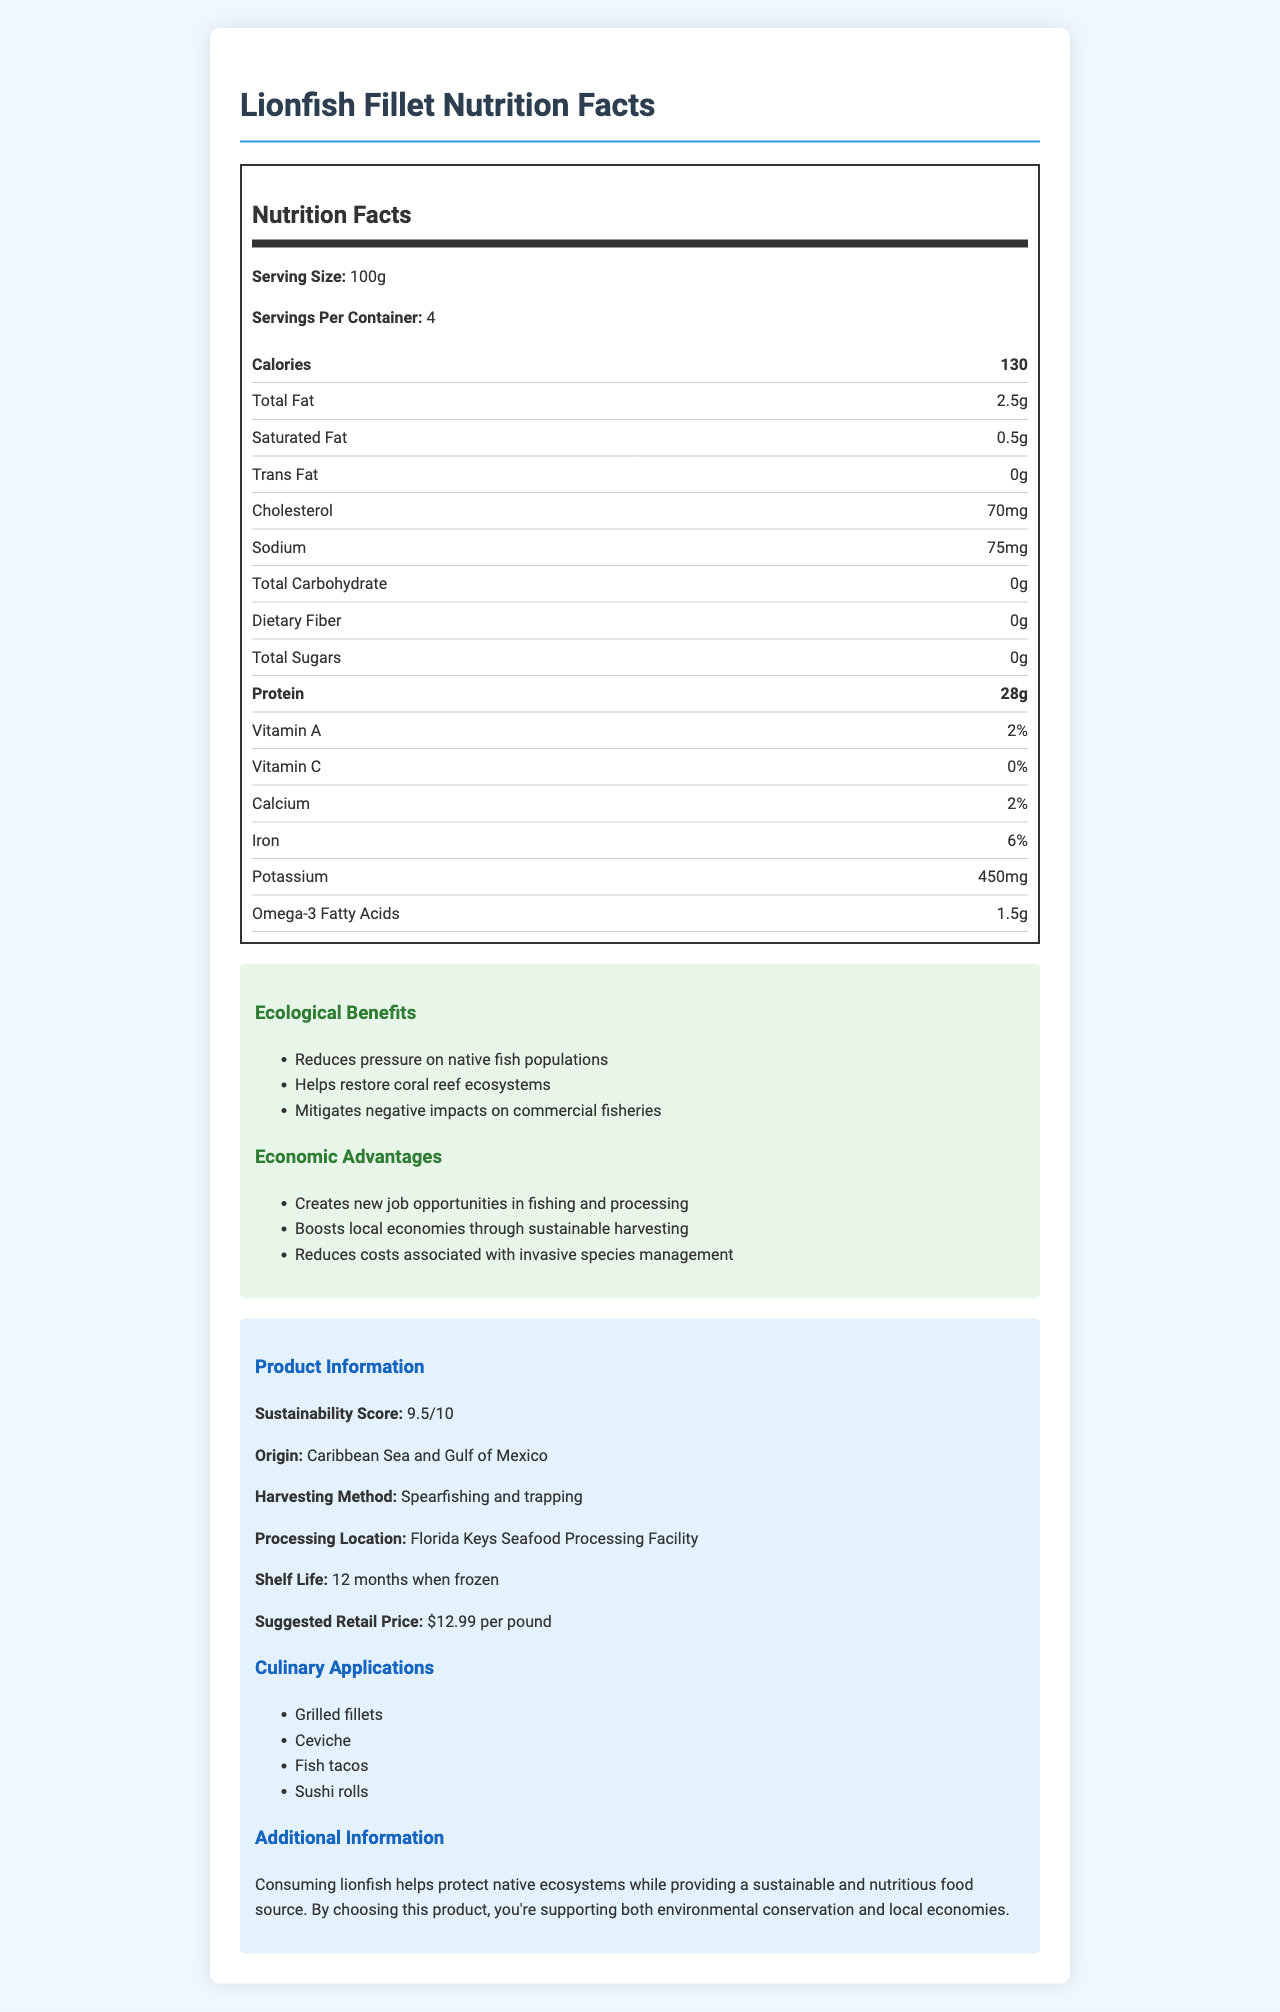what is the serving size of the Lionfish Fillet? According to the nutrition label, the serving size is listed as 100g.
Answer: 100g how many servings are in each container? The document states there are 4 servings per container.
Answer: 4 how much protein is in one serving? The nutrition item list shows that each serving of Lionfish Fillet contains 28 grams of protein.
Answer: 28g what is the sustainability score of the Lionfish Fillet? The document mentions that the sustainability score for the Lionfish Fillet is 9.5 out of 10.
Answer: 9.5 where is the Lionfish Fillet processed? Under the Product Information section, it states that the processing location is the Florida Keys Seafood Processing Facility.
Answer: Florida Keys Seafood Processing Facility which of the following is NOT an ecological benefit of consuming Lionfish Fillet?
A. Helps restore coral reef ecosystems
B. Reduces costs associated with invasive species management
C. Reduces pressure on native fish populations
D. Mitigates negative impacts on commercial fisheries Option B is an economic advantage, not an ecological benefit. The ecological benefits listed are: restoring coral reef ecosystems, reducing pressure on native fish populations, and mitigating negative impacts on commercial fisheries.
Answer: B which of the following culinary applications is NOT suggested for Lionfish Fillet?
A. Grilled fillets
B. Ceviche
C. Ice cream
D. Sushi rolls The culinary applications listed are grilled fillets, ceviche, fish tacos, and sushi rolls. Ice cream is not a suggested application.
Answer: C can consuming Lionfish Fillet help protect native ecosystems? Yes, the additional information section mentions that consuming Lionfish helps to protect native ecosystems.
Answer: Yes summarize the main idea of the document. The summary description captures all the key points and highlights in the document: nutritional facts, ecological and economic benefits, sustainability, and product applications.
Answer: The document provides detailed nutritional information about Lionfish Fillet, highlighting its ecological benefits and economic advantages. It also gives information on the product's sustainability score, origin, harvesting and processing methods, shelf life, suggested retail price, and culinary applications. By promoting the consumption of Lionfish, the document emphasizes supporting environmental conservation and local economies. what are the total carbohydrates in one serving of Lionfish Fillet? The nutrition facts state that there are no carbohydrates (0g) in one serving of Lionfish Fillet.
Answer: 0g how much omega-3 fatty acids does one serving of the Lionfish Fillet contain? The nutrition item list shows that there are 1.5 grams of omega-3 fatty acids in one serving.
Answer: 1.5g how does the harvesting of Lionfish create new job opportunities? The economic advantages section states that the harvesting of Lionfish creates new job opportunities in fishing and processing.
Answer: Creates new job opportunities in fishing and processing does this document provide specific information on the historical population trend of Lionfish? The document does not contain information regarding the historical population trend of Lionfish. It focuses on nutritional facts, benefits, and economic advantages, without delving into population data.
Answer: No 